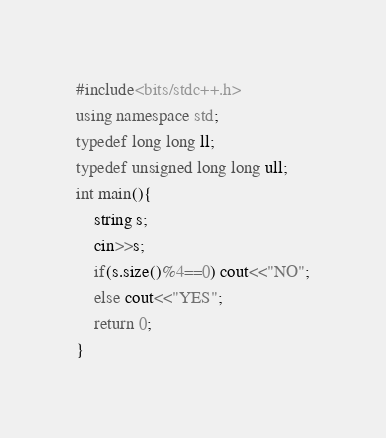Convert code to text. <code><loc_0><loc_0><loc_500><loc_500><_C++_>#include<bits/stdc++.h>
using namespace std;
typedef long long ll;
typedef unsigned long long ull;
int main(){
	string s;
	cin>>s;
	if(s.size()%4==0) cout<<"NO";
	else cout<<"YES";
	return 0;
}
</code> 